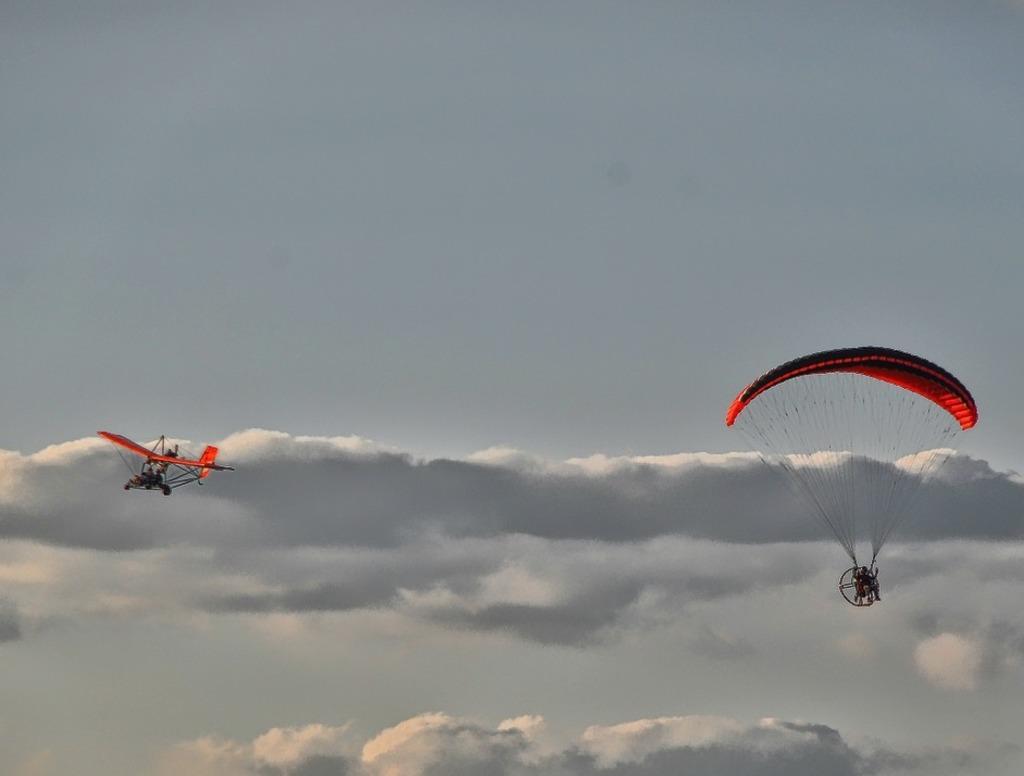Please provide a concise description of this image. In the foreground of this image, on the right, there is a parachute. On the left, there is an airplane. In the background, there is the sky and the cloud. 